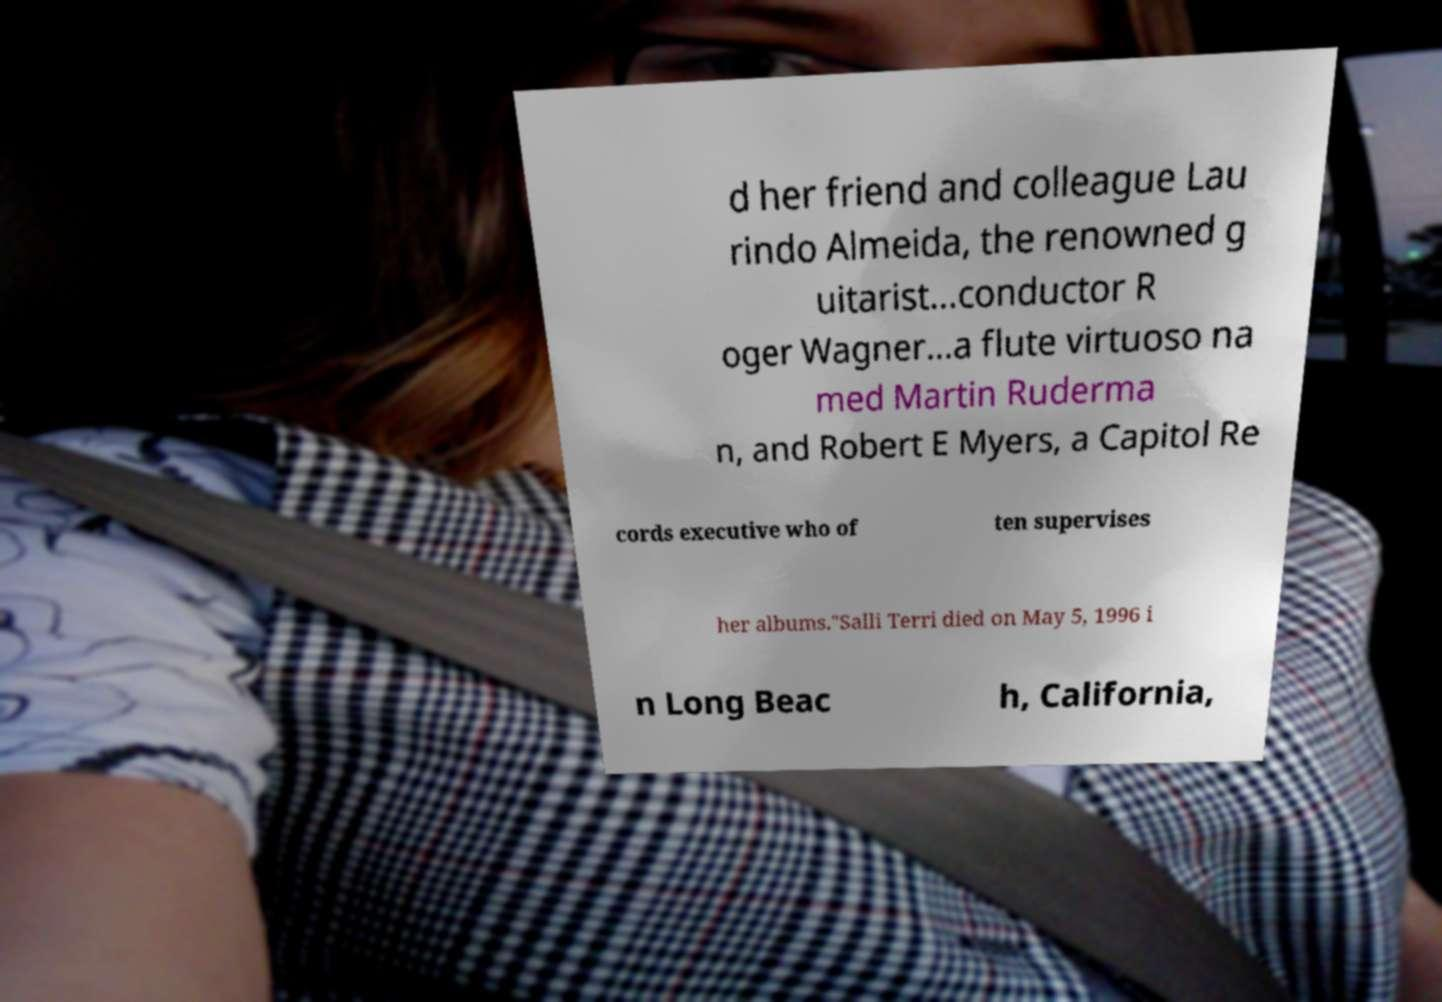Can you accurately transcribe the text from the provided image for me? d her friend and colleague Lau rindo Almeida, the renowned g uitarist…conductor R oger Wagner…a flute virtuoso na med Martin Ruderma n, and Robert E Myers, a Capitol Re cords executive who of ten supervises her albums."Salli Terri died on May 5, 1996 i n Long Beac h, California, 